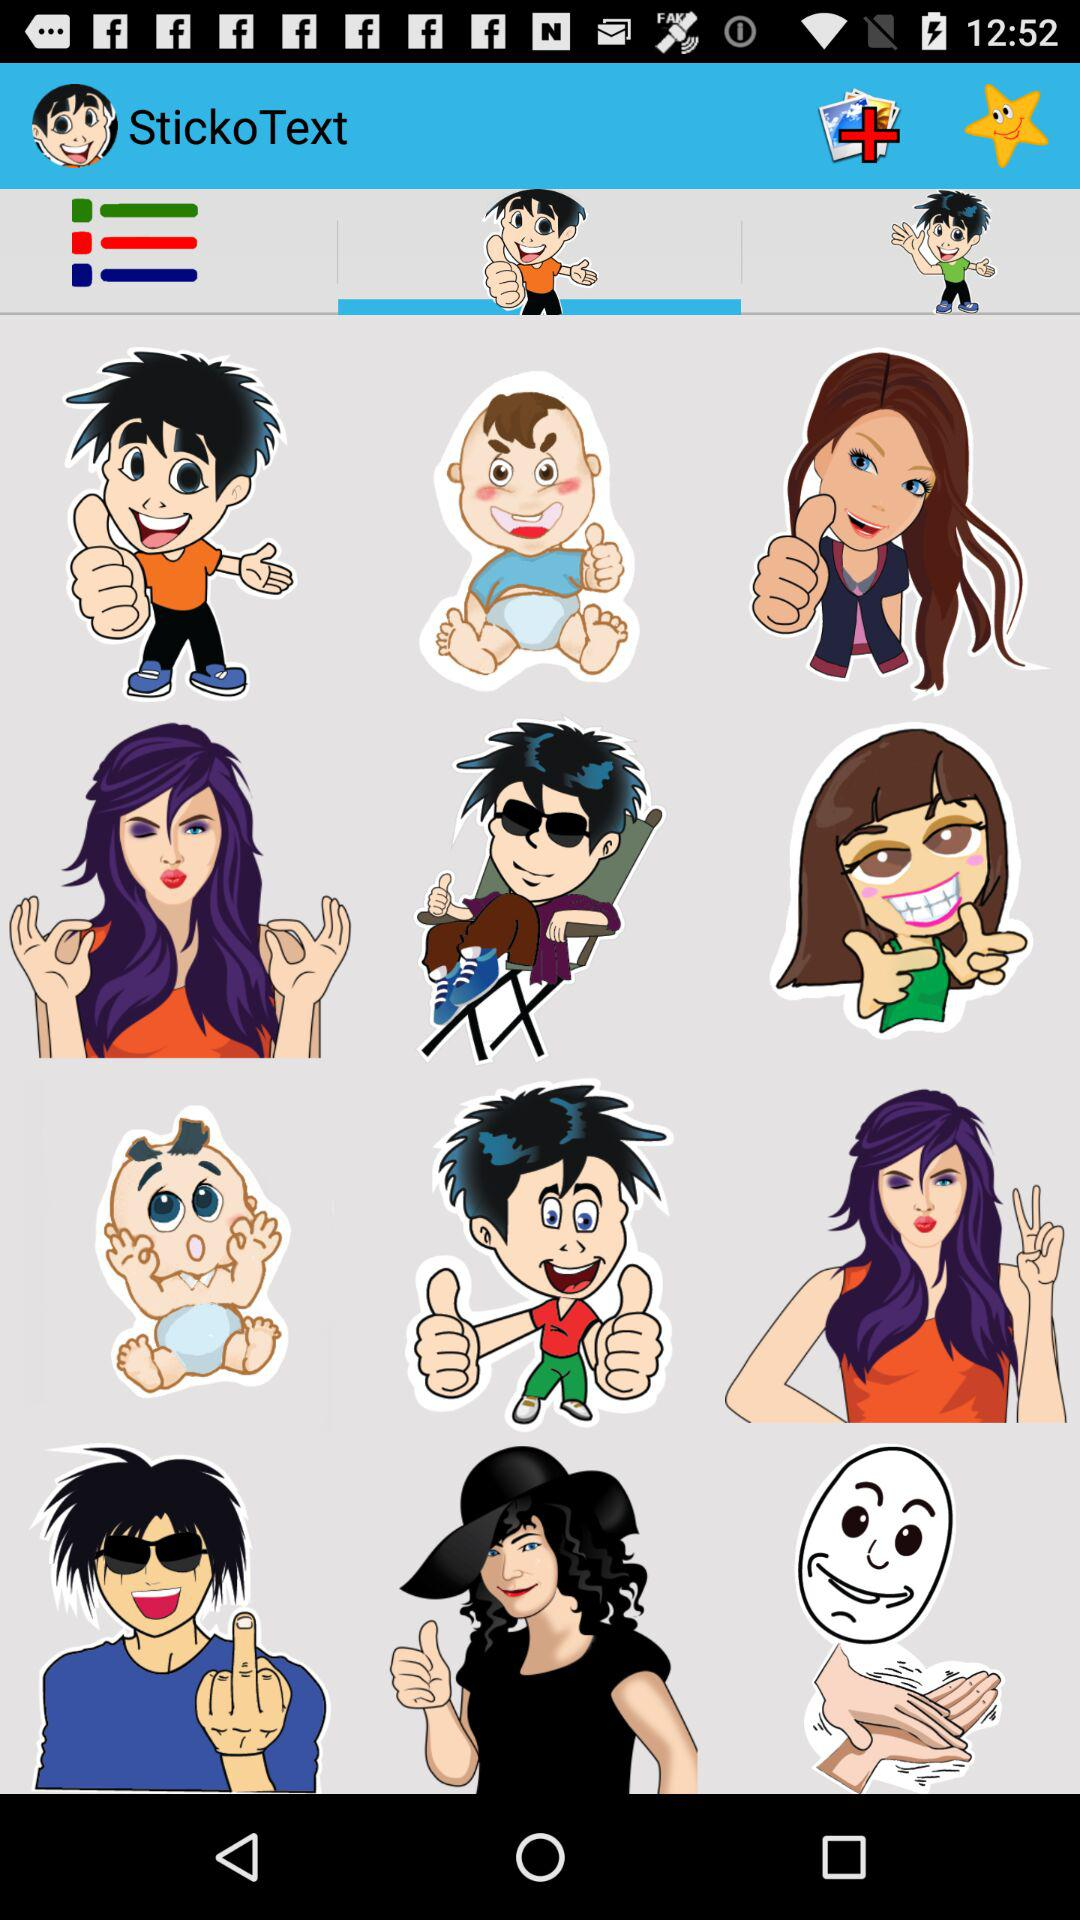What is the application name? The application name is "StickoText". 